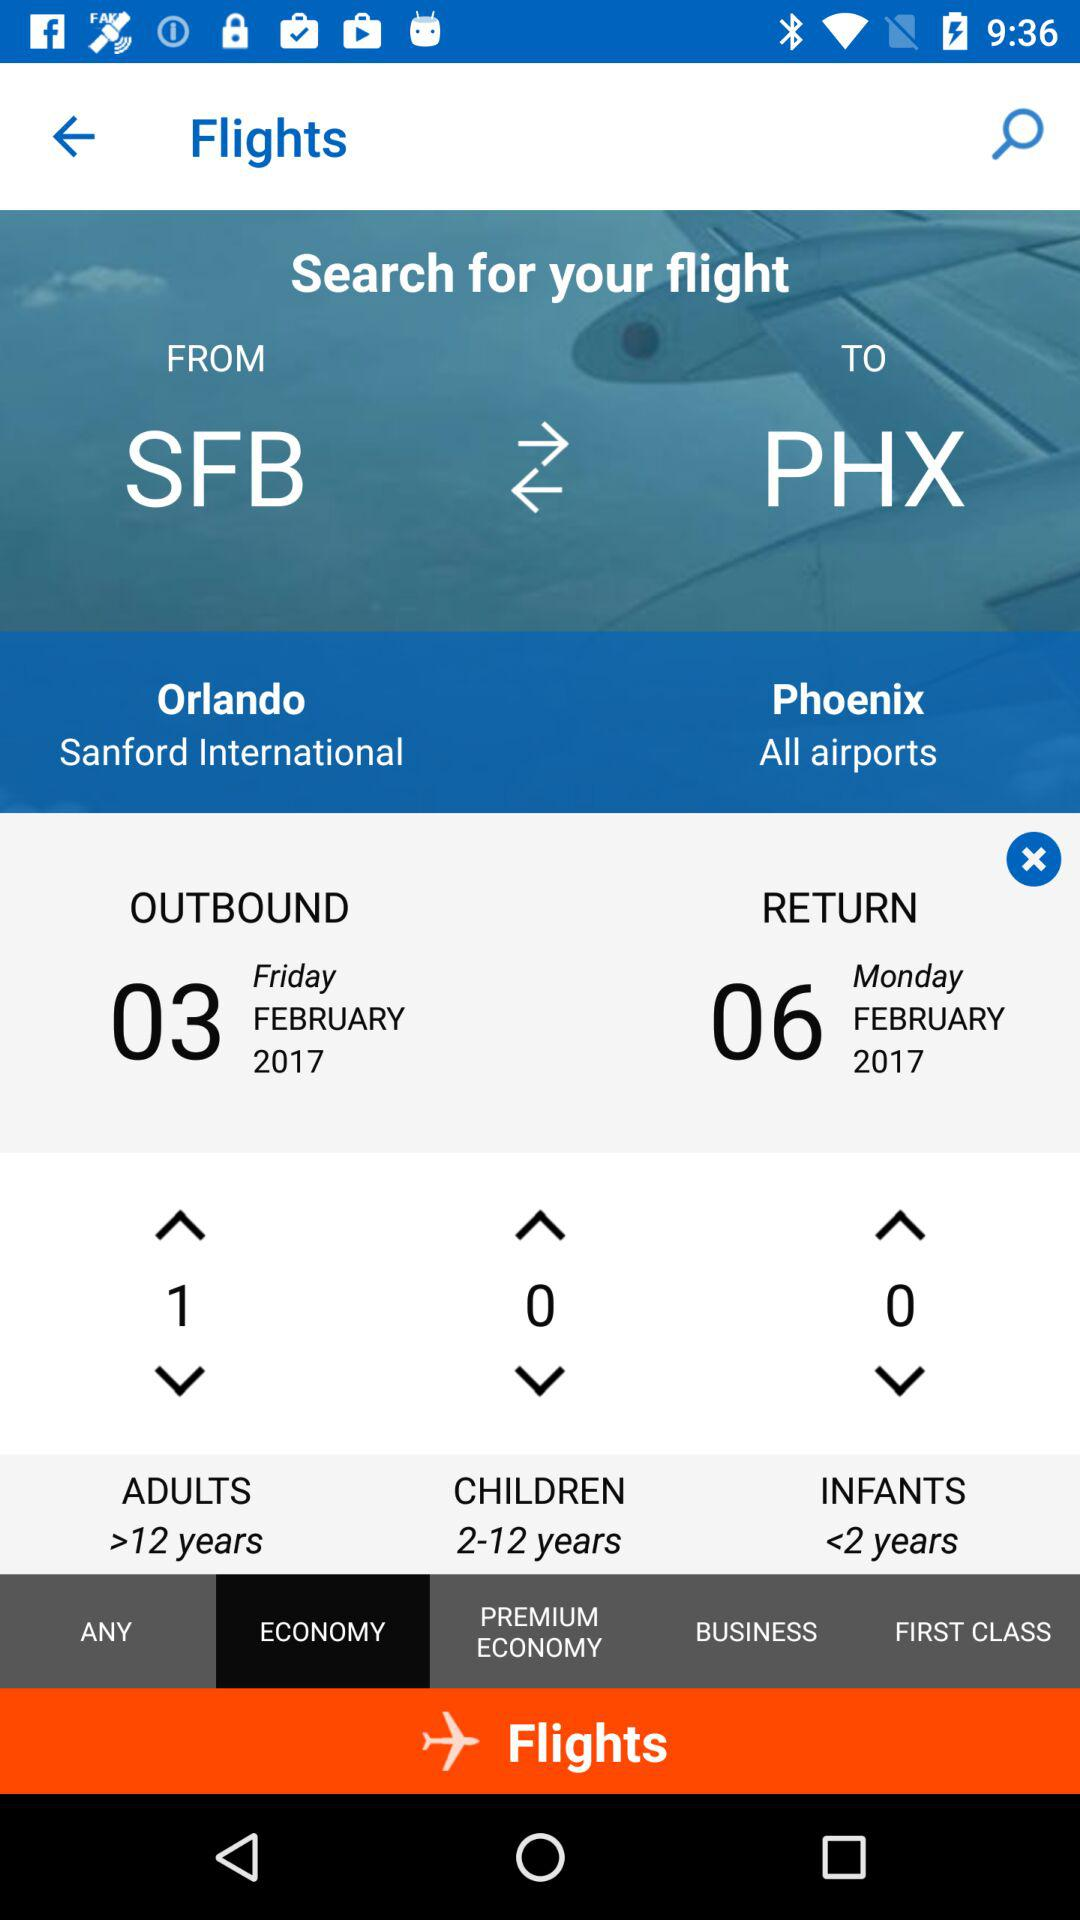What is the day on February 3? The day is Friday. 